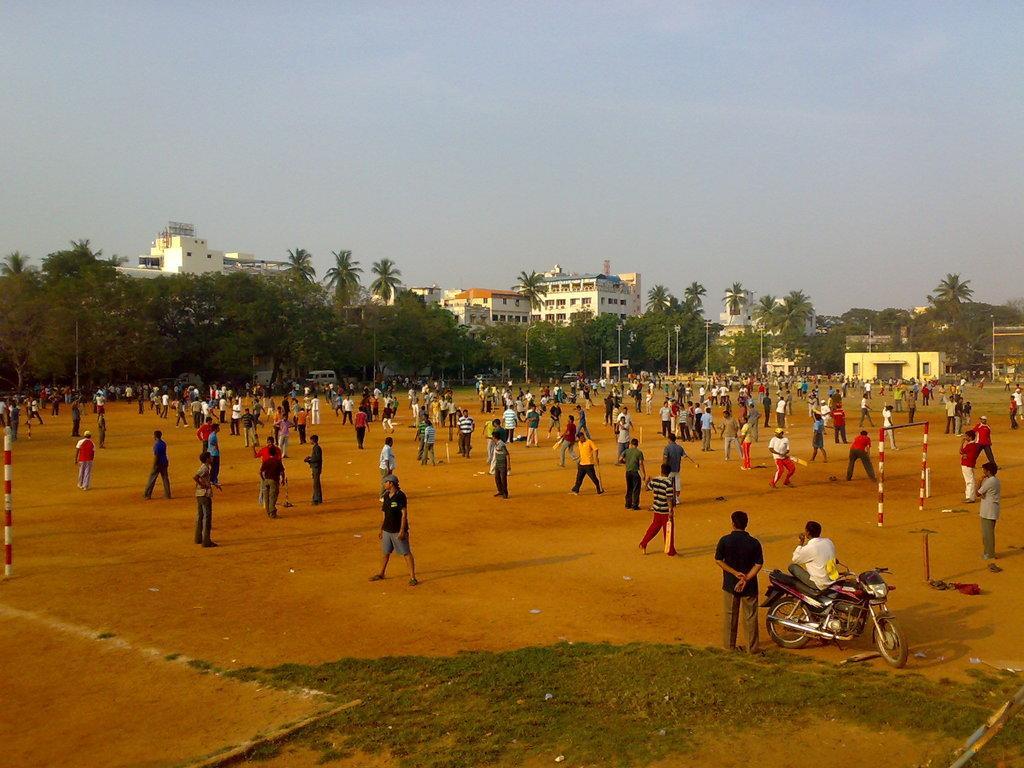Could you give a brief overview of what you see in this image? This is a ground. In this ground there are many people. On the right side there is a person sitting on a motorcycle. In the background there are trees, buildings and sky. 